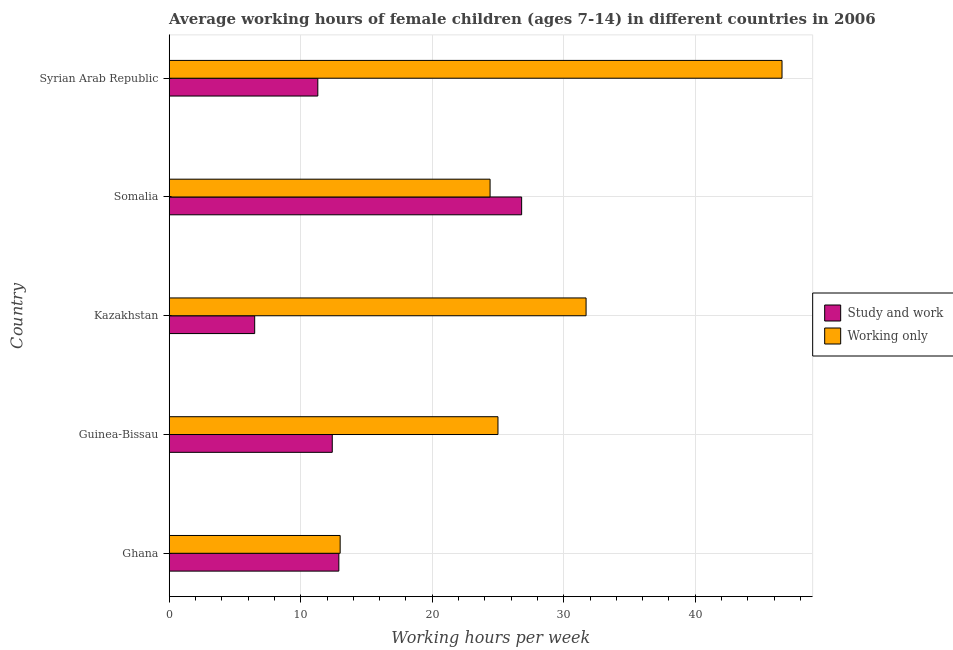Are the number of bars per tick equal to the number of legend labels?
Keep it short and to the point. Yes. Are the number of bars on each tick of the Y-axis equal?
Offer a terse response. Yes. How many bars are there on the 4th tick from the top?
Keep it short and to the point. 2. What is the label of the 4th group of bars from the top?
Your response must be concise. Guinea-Bissau. Across all countries, what is the maximum average working hour of children involved in study and work?
Provide a succinct answer. 26.8. Across all countries, what is the minimum average working hour of children involved in only work?
Your response must be concise. 13. In which country was the average working hour of children involved in only work maximum?
Offer a very short reply. Syrian Arab Republic. In which country was the average working hour of children involved in only work minimum?
Provide a succinct answer. Ghana. What is the total average working hour of children involved in study and work in the graph?
Provide a short and direct response. 69.9. What is the difference between the average working hour of children involved in only work in Somalia and the average working hour of children involved in study and work in Guinea-Bissau?
Your response must be concise. 12. What is the average average working hour of children involved in study and work per country?
Make the answer very short. 13.98. What is the difference between the average working hour of children involved in only work and average working hour of children involved in study and work in Ghana?
Keep it short and to the point. 0.1. In how many countries, is the average working hour of children involved in only work greater than 24 hours?
Ensure brevity in your answer.  4. What is the ratio of the average working hour of children involved in only work in Ghana to that in Kazakhstan?
Offer a terse response. 0.41. Is the average working hour of children involved in study and work in Guinea-Bissau less than that in Somalia?
Your answer should be very brief. Yes. Is the difference between the average working hour of children involved in study and work in Kazakhstan and Somalia greater than the difference between the average working hour of children involved in only work in Kazakhstan and Somalia?
Your answer should be very brief. No. What is the difference between the highest and the second highest average working hour of children involved in only work?
Provide a succinct answer. 14.9. What is the difference between the highest and the lowest average working hour of children involved in study and work?
Provide a short and direct response. 20.3. In how many countries, is the average working hour of children involved in only work greater than the average average working hour of children involved in only work taken over all countries?
Offer a very short reply. 2. Is the sum of the average working hour of children involved in study and work in Ghana and Somalia greater than the maximum average working hour of children involved in only work across all countries?
Provide a succinct answer. No. What does the 1st bar from the top in Somalia represents?
Make the answer very short. Working only. What does the 2nd bar from the bottom in Ghana represents?
Your answer should be very brief. Working only. How many bars are there?
Provide a short and direct response. 10. Are all the bars in the graph horizontal?
Provide a short and direct response. Yes. What is the difference between two consecutive major ticks on the X-axis?
Ensure brevity in your answer.  10. Does the graph contain grids?
Give a very brief answer. Yes. Where does the legend appear in the graph?
Keep it short and to the point. Center right. How are the legend labels stacked?
Keep it short and to the point. Vertical. What is the title of the graph?
Keep it short and to the point. Average working hours of female children (ages 7-14) in different countries in 2006. Does "Male population" appear as one of the legend labels in the graph?
Your answer should be compact. No. What is the label or title of the X-axis?
Ensure brevity in your answer.  Working hours per week. What is the Working hours per week of Study and work in Ghana?
Offer a terse response. 12.9. What is the Working hours per week in Working only in Guinea-Bissau?
Provide a succinct answer. 25. What is the Working hours per week in Working only in Kazakhstan?
Provide a short and direct response. 31.7. What is the Working hours per week of Study and work in Somalia?
Your answer should be compact. 26.8. What is the Working hours per week of Working only in Somalia?
Ensure brevity in your answer.  24.4. What is the Working hours per week in Study and work in Syrian Arab Republic?
Your response must be concise. 11.3. What is the Working hours per week of Working only in Syrian Arab Republic?
Provide a short and direct response. 46.6. Across all countries, what is the maximum Working hours per week in Study and work?
Offer a terse response. 26.8. Across all countries, what is the maximum Working hours per week of Working only?
Your answer should be very brief. 46.6. Across all countries, what is the minimum Working hours per week of Study and work?
Keep it short and to the point. 6.5. What is the total Working hours per week of Study and work in the graph?
Offer a terse response. 69.9. What is the total Working hours per week in Working only in the graph?
Keep it short and to the point. 140.7. What is the difference between the Working hours per week in Study and work in Ghana and that in Guinea-Bissau?
Provide a succinct answer. 0.5. What is the difference between the Working hours per week in Study and work in Ghana and that in Kazakhstan?
Your response must be concise. 6.4. What is the difference between the Working hours per week in Working only in Ghana and that in Kazakhstan?
Offer a terse response. -18.7. What is the difference between the Working hours per week in Study and work in Ghana and that in Somalia?
Provide a succinct answer. -13.9. What is the difference between the Working hours per week in Working only in Ghana and that in Somalia?
Make the answer very short. -11.4. What is the difference between the Working hours per week in Study and work in Ghana and that in Syrian Arab Republic?
Provide a short and direct response. 1.6. What is the difference between the Working hours per week in Working only in Ghana and that in Syrian Arab Republic?
Keep it short and to the point. -33.6. What is the difference between the Working hours per week of Working only in Guinea-Bissau and that in Kazakhstan?
Give a very brief answer. -6.7. What is the difference between the Working hours per week of Study and work in Guinea-Bissau and that in Somalia?
Keep it short and to the point. -14.4. What is the difference between the Working hours per week in Working only in Guinea-Bissau and that in Somalia?
Provide a succinct answer. 0.6. What is the difference between the Working hours per week of Study and work in Guinea-Bissau and that in Syrian Arab Republic?
Ensure brevity in your answer.  1.1. What is the difference between the Working hours per week in Working only in Guinea-Bissau and that in Syrian Arab Republic?
Make the answer very short. -21.6. What is the difference between the Working hours per week in Study and work in Kazakhstan and that in Somalia?
Provide a short and direct response. -20.3. What is the difference between the Working hours per week of Working only in Kazakhstan and that in Somalia?
Make the answer very short. 7.3. What is the difference between the Working hours per week of Study and work in Kazakhstan and that in Syrian Arab Republic?
Provide a short and direct response. -4.8. What is the difference between the Working hours per week in Working only in Kazakhstan and that in Syrian Arab Republic?
Ensure brevity in your answer.  -14.9. What is the difference between the Working hours per week of Study and work in Somalia and that in Syrian Arab Republic?
Provide a short and direct response. 15.5. What is the difference between the Working hours per week in Working only in Somalia and that in Syrian Arab Republic?
Keep it short and to the point. -22.2. What is the difference between the Working hours per week of Study and work in Ghana and the Working hours per week of Working only in Guinea-Bissau?
Your answer should be very brief. -12.1. What is the difference between the Working hours per week of Study and work in Ghana and the Working hours per week of Working only in Kazakhstan?
Provide a short and direct response. -18.8. What is the difference between the Working hours per week in Study and work in Ghana and the Working hours per week in Working only in Somalia?
Provide a short and direct response. -11.5. What is the difference between the Working hours per week in Study and work in Ghana and the Working hours per week in Working only in Syrian Arab Republic?
Give a very brief answer. -33.7. What is the difference between the Working hours per week of Study and work in Guinea-Bissau and the Working hours per week of Working only in Kazakhstan?
Give a very brief answer. -19.3. What is the difference between the Working hours per week in Study and work in Guinea-Bissau and the Working hours per week in Working only in Syrian Arab Republic?
Keep it short and to the point. -34.2. What is the difference between the Working hours per week in Study and work in Kazakhstan and the Working hours per week in Working only in Somalia?
Provide a short and direct response. -17.9. What is the difference between the Working hours per week of Study and work in Kazakhstan and the Working hours per week of Working only in Syrian Arab Republic?
Provide a succinct answer. -40.1. What is the difference between the Working hours per week in Study and work in Somalia and the Working hours per week in Working only in Syrian Arab Republic?
Offer a very short reply. -19.8. What is the average Working hours per week in Study and work per country?
Offer a terse response. 13.98. What is the average Working hours per week in Working only per country?
Your answer should be compact. 28.14. What is the difference between the Working hours per week in Study and work and Working hours per week in Working only in Kazakhstan?
Offer a very short reply. -25.2. What is the difference between the Working hours per week of Study and work and Working hours per week of Working only in Somalia?
Your answer should be very brief. 2.4. What is the difference between the Working hours per week in Study and work and Working hours per week in Working only in Syrian Arab Republic?
Your response must be concise. -35.3. What is the ratio of the Working hours per week in Study and work in Ghana to that in Guinea-Bissau?
Give a very brief answer. 1.04. What is the ratio of the Working hours per week in Working only in Ghana to that in Guinea-Bissau?
Offer a very short reply. 0.52. What is the ratio of the Working hours per week in Study and work in Ghana to that in Kazakhstan?
Ensure brevity in your answer.  1.98. What is the ratio of the Working hours per week of Working only in Ghana to that in Kazakhstan?
Give a very brief answer. 0.41. What is the ratio of the Working hours per week of Study and work in Ghana to that in Somalia?
Your answer should be compact. 0.48. What is the ratio of the Working hours per week in Working only in Ghana to that in Somalia?
Your answer should be compact. 0.53. What is the ratio of the Working hours per week in Study and work in Ghana to that in Syrian Arab Republic?
Your answer should be very brief. 1.14. What is the ratio of the Working hours per week in Working only in Ghana to that in Syrian Arab Republic?
Keep it short and to the point. 0.28. What is the ratio of the Working hours per week of Study and work in Guinea-Bissau to that in Kazakhstan?
Provide a short and direct response. 1.91. What is the ratio of the Working hours per week in Working only in Guinea-Bissau to that in Kazakhstan?
Provide a succinct answer. 0.79. What is the ratio of the Working hours per week in Study and work in Guinea-Bissau to that in Somalia?
Provide a short and direct response. 0.46. What is the ratio of the Working hours per week in Working only in Guinea-Bissau to that in Somalia?
Your answer should be very brief. 1.02. What is the ratio of the Working hours per week in Study and work in Guinea-Bissau to that in Syrian Arab Republic?
Keep it short and to the point. 1.1. What is the ratio of the Working hours per week in Working only in Guinea-Bissau to that in Syrian Arab Republic?
Your answer should be compact. 0.54. What is the ratio of the Working hours per week of Study and work in Kazakhstan to that in Somalia?
Provide a short and direct response. 0.24. What is the ratio of the Working hours per week of Working only in Kazakhstan to that in Somalia?
Your answer should be compact. 1.3. What is the ratio of the Working hours per week in Study and work in Kazakhstan to that in Syrian Arab Republic?
Give a very brief answer. 0.58. What is the ratio of the Working hours per week in Working only in Kazakhstan to that in Syrian Arab Republic?
Provide a succinct answer. 0.68. What is the ratio of the Working hours per week of Study and work in Somalia to that in Syrian Arab Republic?
Your answer should be compact. 2.37. What is the ratio of the Working hours per week of Working only in Somalia to that in Syrian Arab Republic?
Ensure brevity in your answer.  0.52. What is the difference between the highest and the second highest Working hours per week of Working only?
Make the answer very short. 14.9. What is the difference between the highest and the lowest Working hours per week in Study and work?
Offer a terse response. 20.3. What is the difference between the highest and the lowest Working hours per week in Working only?
Your answer should be very brief. 33.6. 